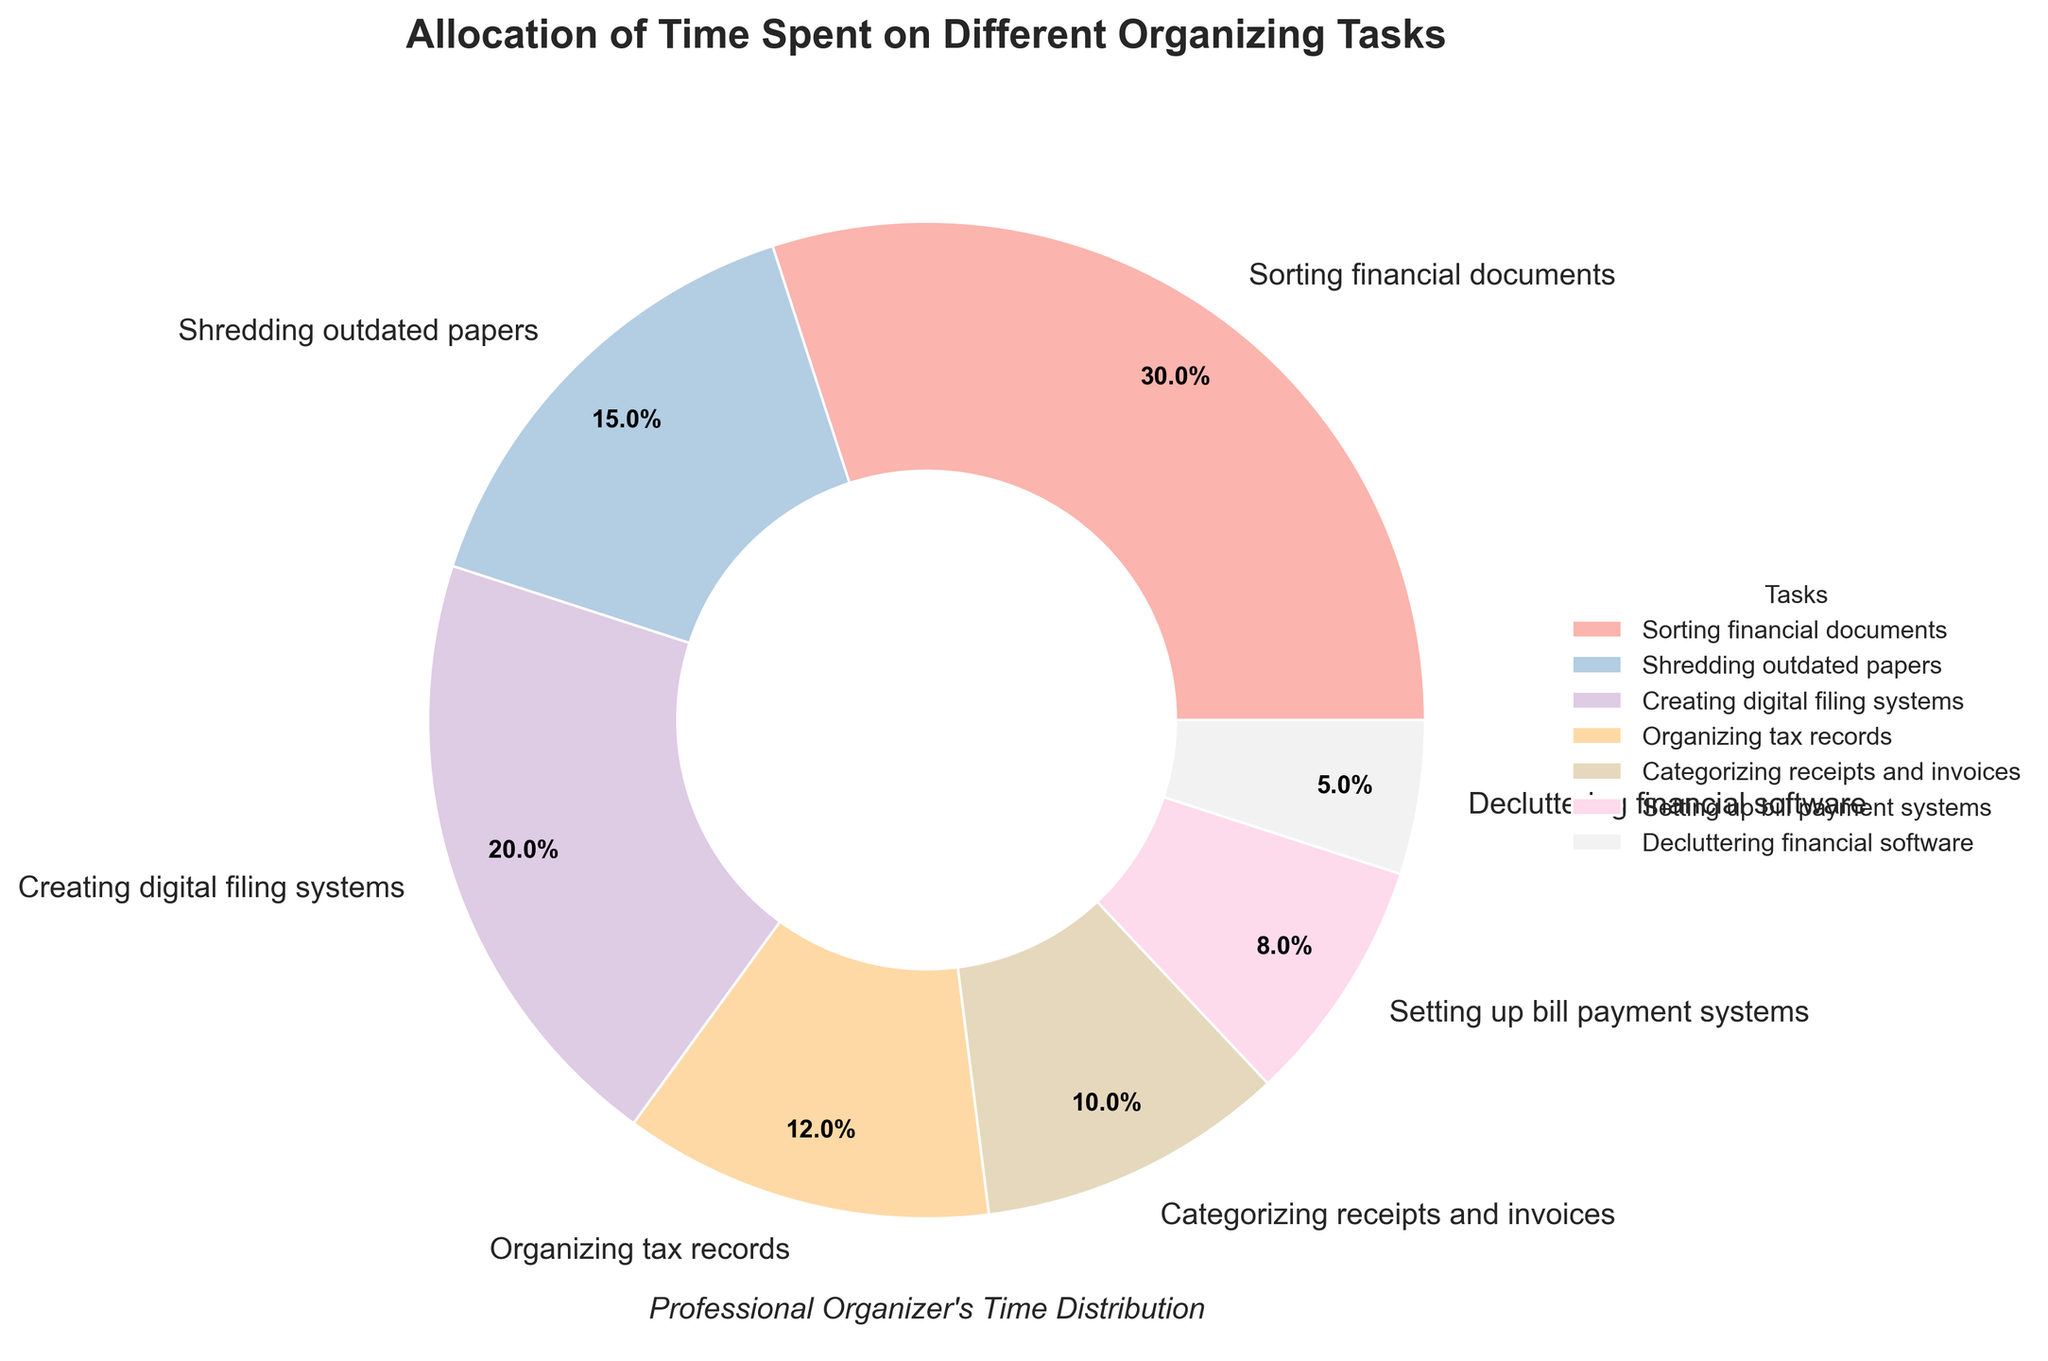What task takes the highest percentage of time? The task with the highest percentage in the pie chart is "Sorting financial documents" with a percentage label of 30%.
Answer: Sorting financial documents Which task takes more time: Organizing tax records or Categorizing receipts and invoices? The pie chart shows that Organizing tax records takes 12% of time, whereas Categorizing receipts and invoices takes 10%. So, Organizing tax records takes more time.
Answer: Organizing tax records What is the combined percentage of time spent on Shredding outdated papers and Setting up bill payment systems? Shredding outdated papers takes 15% of the time and Setting up bill payment systems takes 8%. Adding these up: 15% + 8% = 23%.
Answer: 23% How much more time is spent on Creating digital filing systems compared to Decluttering financial software? The percentage spent on Creating digital filing systems is 20% and on Decluttering financial software is 5%. The difference is 20% - 5% = 15%.
Answer: 15% Which task occupies the smallest portion of the pie chart? The smallest portion of the pie chart is labeled as "Decluttering financial software" with a percentage of 5%.
Answer: Decluttering financial software Is the time spent on Categorizing receipts and invoices more than half the time spent on Sorting financial documents? Sorting financial documents takes 30% of the time. Half of this time is 15%. Categorizing receipts and invoices takes 10%, which is less than 15%.
Answer: No Does Creating digital filing systems take up more time than both Shredding outdated papers and Setting up bill payment systems combined? Creating digital filing systems takes 20% of the time. Shredding outdated papers takes 15% and Setting up bill payment systems takes 8%. Combined, these two tasks take 15% + 8% = 23%. 20% is less than 23%, so no.
Answer: No What is the average percentage of time spent on Organizing tax records, Categorizing receipts and invoices, and Setting up bill payment systems? Add the percentages of the three tasks: 12% (Organizing tax records) + 10% (Categorizing receipts and invoices) + 8% (Setting up bill payment systems) = 30%. Divide by 3 to find the average: 30% / 3 = 10%.
Answer: 10% Which tasks together occupy exactly half of the pie chart? Half of the pie chart is 50%. The tasks that add up to 50% are Creating digital filing systems (20%) and Shredding outdated papers (15%) and Setting up bill payment systems (8%) and Decluttering financial software (5%): 20% + 15% + 8% + 5% = 48%. This does not fit, so try other combinations which fit exactly half. Sorting financial documents (30%) and Organizing tax records (12%) and Categorizing receipts and invoices (10%) add up to: 30% + 12% + 10% = 52%. No fitting combination found. The tasks Creating digital filing systems (20%) and Organizing tax records (12%) and Shredding outdated papers (15%) Add up to 47%, thus no perfect 50% match.
Answer: None 